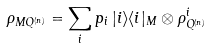Convert formula to latex. <formula><loc_0><loc_0><loc_500><loc_500>\rho _ { M Q ^ { ( n ) } } = \sum _ { i } p _ { i } \, | i \rangle \langle i | _ { M } \otimes \rho ^ { i } _ { Q ^ { ( n ) } }</formula> 